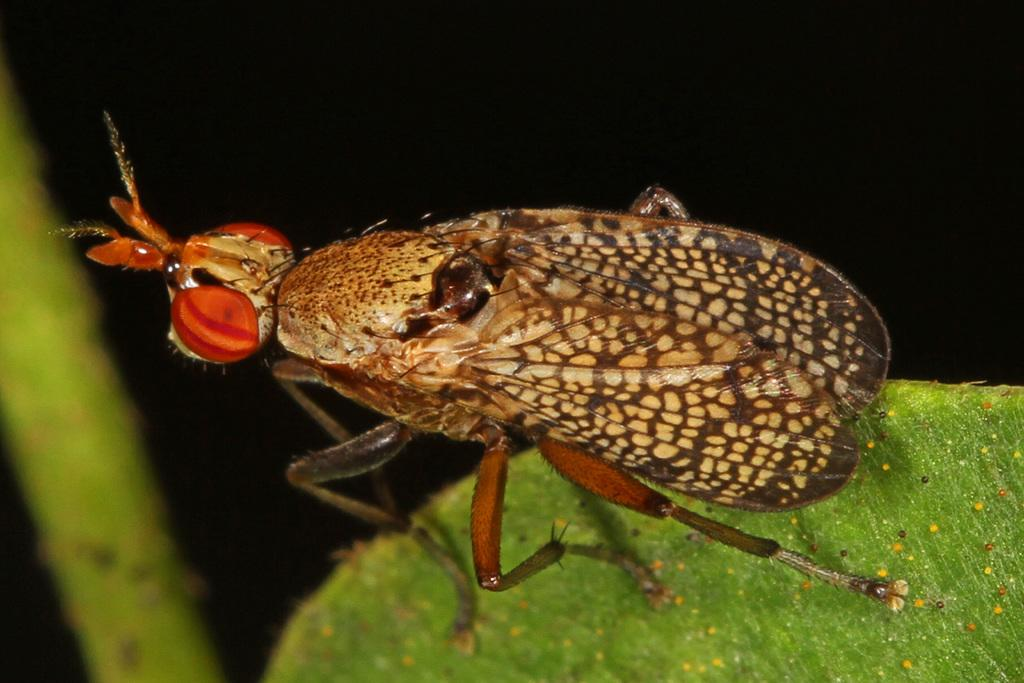What is present on the green leaf in the image? There is an insect on the green leaf in the image. Can you describe the colors of the insect? The insect has orange, brown, and cream colors. What is the background color of the image? The background of the image is black. What caption is written on the image? There is no caption present in the image. Can you see a playground in the image? There is no playground present in the image. 